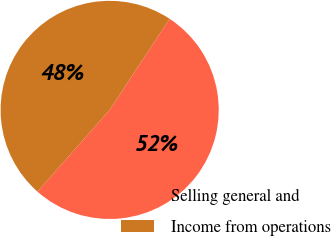Convert chart to OTSL. <chart><loc_0><loc_0><loc_500><loc_500><pie_chart><fcel>Selling general and<fcel>Income from operations<nl><fcel>52.26%<fcel>47.74%<nl></chart> 